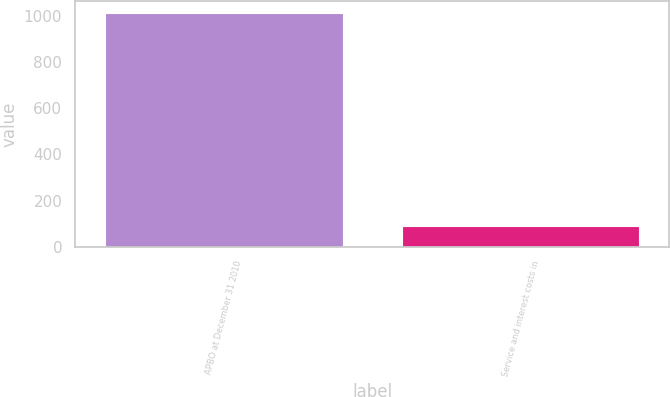Convert chart to OTSL. <chart><loc_0><loc_0><loc_500><loc_500><bar_chart><fcel>APBO at December 31 2010<fcel>Service and interest costs in<nl><fcel>1012<fcel>91<nl></chart> 